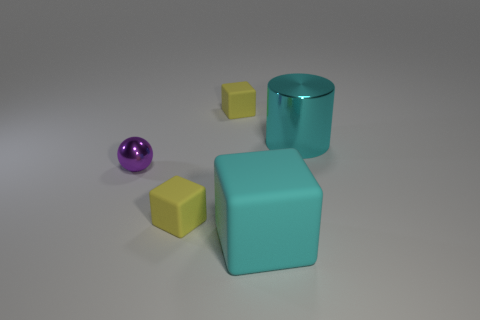Add 2 small rubber objects. How many small rubber objects are left? 4 Add 2 cylinders. How many cylinders exist? 3 Add 4 big blue metallic cylinders. How many objects exist? 9 Subtract all yellow blocks. How many blocks are left? 1 Subtract all yellow matte blocks. How many blocks are left? 1 Subtract 0 blue balls. How many objects are left? 5 Subtract all cubes. How many objects are left? 2 Subtract 1 cubes. How many cubes are left? 2 Subtract all green blocks. Subtract all blue cylinders. How many blocks are left? 3 Subtract all red cylinders. How many yellow cubes are left? 2 